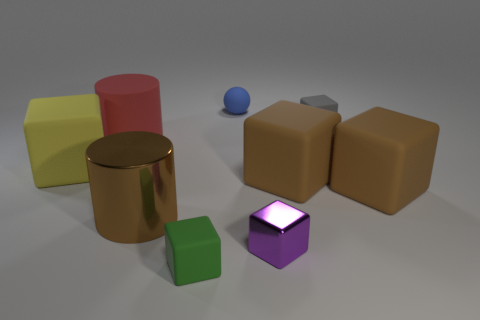What is the large cube to the left of the small matte cube in front of the large brown thing that is to the left of the small blue matte object made of?
Your answer should be very brief. Rubber. What number of objects are either small blocks that are on the right side of the small green block or red cylinders?
Give a very brief answer. 3. How many things are either tiny red matte objects or cylinders behind the large brown cylinder?
Provide a succinct answer. 1. What number of yellow things are to the left of the big rubber cube that is to the left of the metallic thing to the right of the brown shiny thing?
Your answer should be very brief. 0. There is another cylinder that is the same size as the red cylinder; what material is it?
Keep it short and to the point. Metal. Are there any other purple objects of the same size as the purple metallic thing?
Your answer should be very brief. No. What is the color of the small metal block?
Make the answer very short. Purple. What is the color of the thing that is behind the small rubber cube that is behind the metallic cylinder?
Keep it short and to the point. Blue. What is the shape of the brown thing to the left of the tiny matte block left of the tiny matte block that is behind the green object?
Your response must be concise. Cylinder. How many tiny things are the same material as the sphere?
Your answer should be compact. 2. 